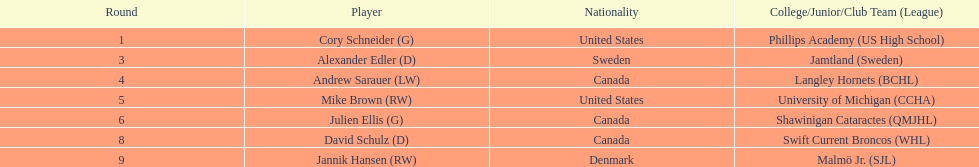Enumerate every athlete selected from canada. Andrew Sarauer (LW), Julien Ellis (G), David Schulz (D). 